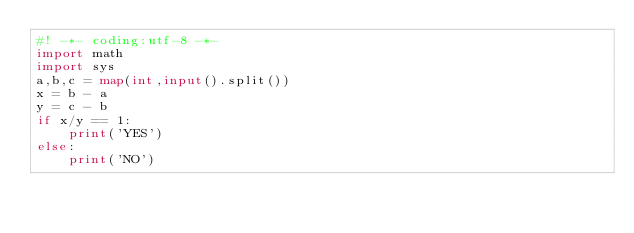<code> <loc_0><loc_0><loc_500><loc_500><_Python_>#! -*- coding:utf-8 -*-
import math
import sys
a,b,c = map(int,input().split())
x = b - a
y = c - b
if x/y == 1:
    print('YES')
else:
    print('NO')
</code> 